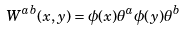Convert formula to latex. <formula><loc_0><loc_0><loc_500><loc_500>W ^ { a b } ( x , y ) = \phi ( x ) \theta ^ { a } \phi ( y ) \theta ^ { b }</formula> 